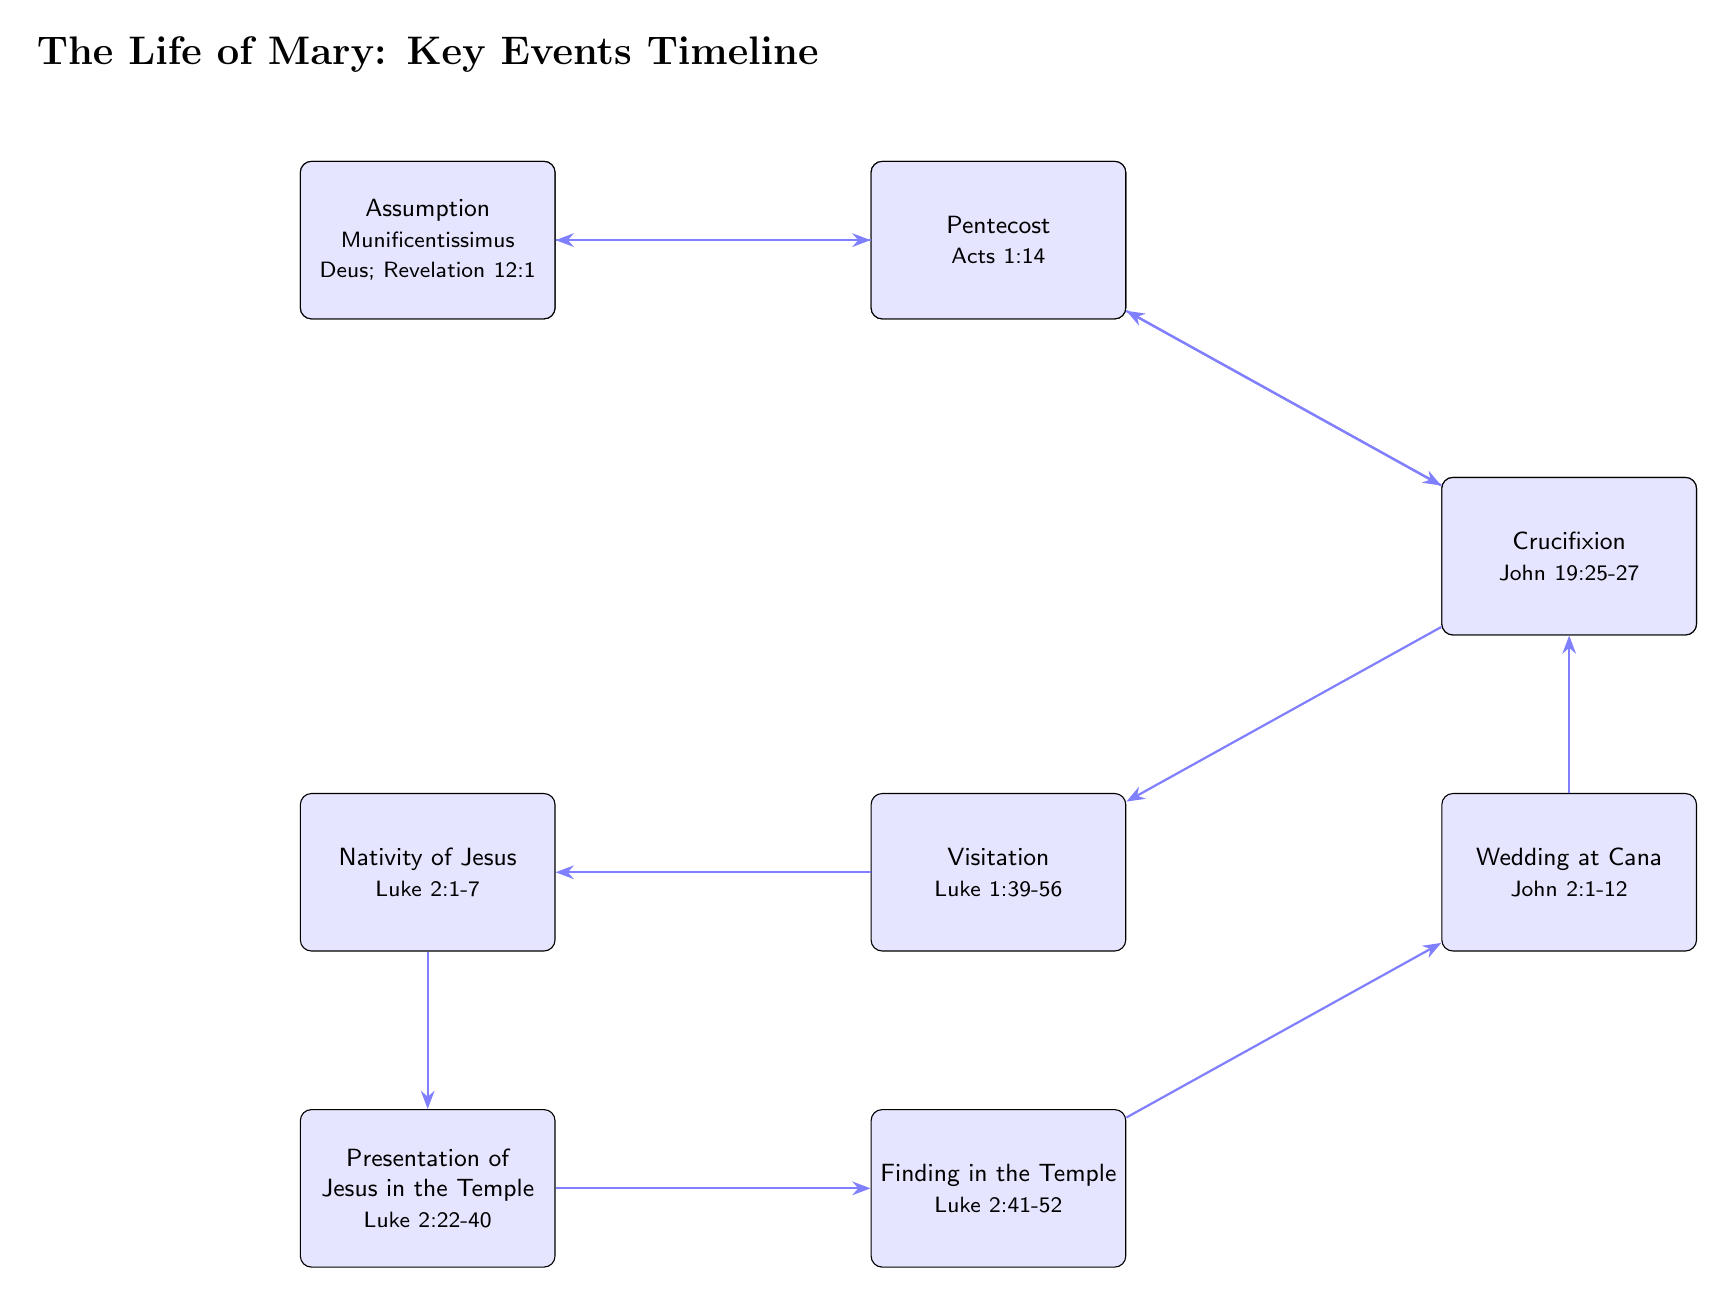What is the first event in Mary's life according to the timeline? The diagram starts with the 'Nativity of Mary' as the first event listed on the leftmost side, which indicates it is the beginning of the timeline.
Answer: Nativity of Mary How many events are listed in the timeline? By counting the nodes in the diagram, there are a total of eleven events presented, reflecting key milestones in Mary's life.
Answer: 11 What event directly follows the Presentation of Mary? Looking at the flow of the arrows in the diagram, the event that comes directly after 'Presentation of Mary' is 'Annunciation'.
Answer: Annunciation Which biblical book refers to the Visitation? The Visitation event references the biblical passage from the book of Luke, which is stated in the diagram, specifically 'Luke 1:39-56'.
Answer: Luke What significant event occurs after the Crucifixion? Following the 'Crucifixion' event in the diagram, the next key milestone is 'Pentecost', which is connected through the arrows indicating the order of events.
Answer: Pentecost From which text do we get the details about Mary's Assumption? The diagram references 'Munificentissimus Deus' and 'Revelation 12:1' in relation to Mary's Assumption, indicating that both are sources discussing this doctrine.
Answer: Munificentissimus Deus; Revelation 12:1 Which event marks the start of Jesus' public ministry? Referring to the outlined timeline and understanding the significance of events, the 'Wedding at Cana' marks the beginning of Jesus' public ministry depicted in the diagram.
Answer: Wedding at Cana What is the last event shown in the timeline? According to the structure of the diagram, 'Assumption' is positioned at the topmost end, which indicates it is the last event in the timeline of Mary's life.
Answer: Assumption 